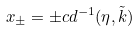Convert formula to latex. <formula><loc_0><loc_0><loc_500><loc_500>x _ { \pm } = \pm c d ^ { - 1 } ( \eta , \tilde { k } )</formula> 